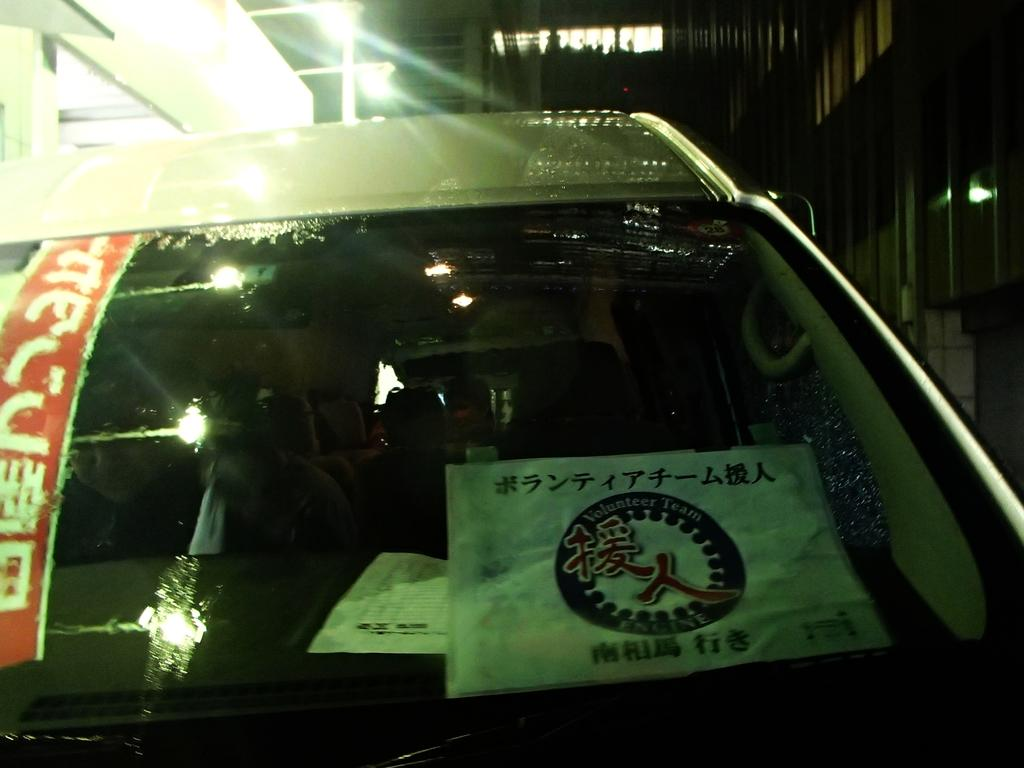What is the main subject in the foreground of the picture? There is a car in the foreground of the picture. What can be seen on the car? The car has stickers on it. What can be seen in the background of the picture? There are buildings, light, windows, and other objects in the background of the picture. Can you see any hands holding a faucet in the image? There are no hands or faucets present in the image. What type of sign can be seen in the background of the picture? There is no sign visible in the background of the picture. 